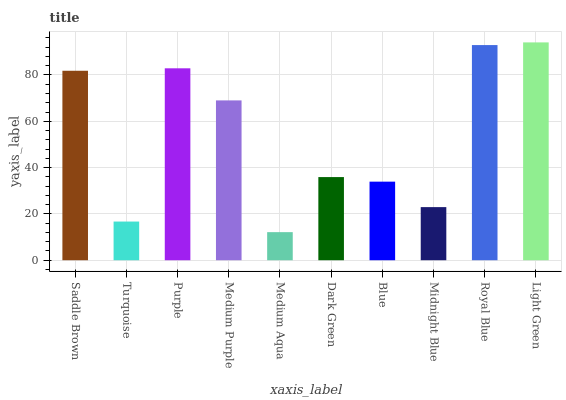Is Medium Aqua the minimum?
Answer yes or no. Yes. Is Light Green the maximum?
Answer yes or no. Yes. Is Turquoise the minimum?
Answer yes or no. No. Is Turquoise the maximum?
Answer yes or no. No. Is Saddle Brown greater than Turquoise?
Answer yes or no. Yes. Is Turquoise less than Saddle Brown?
Answer yes or no. Yes. Is Turquoise greater than Saddle Brown?
Answer yes or no. No. Is Saddle Brown less than Turquoise?
Answer yes or no. No. Is Medium Purple the high median?
Answer yes or no. Yes. Is Dark Green the low median?
Answer yes or no. Yes. Is Purple the high median?
Answer yes or no. No. Is Purple the low median?
Answer yes or no. No. 